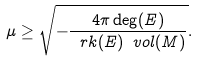<formula> <loc_0><loc_0><loc_500><loc_500>\mu \geq \sqrt { - \frac { 4 \pi \deg ( E ) } { \ r k ( E ) \ v o l ( M ) } } .</formula> 